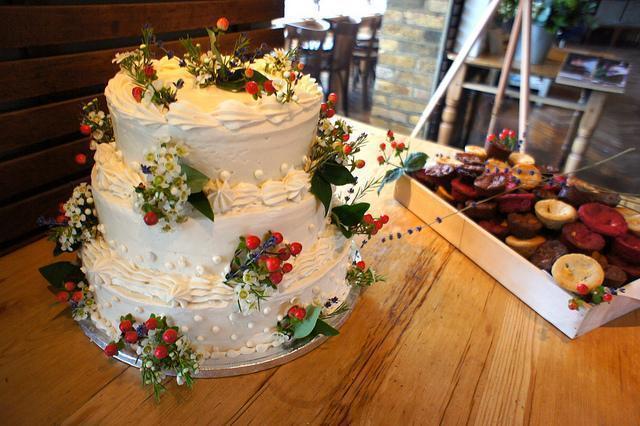Bakers usually charge by the what to make these items?
Choose the correct response and explain in the format: 'Answer: answer
Rationale: rationale.'
Options: Hour, slice, minute, weight. Answer: slice.
Rationale: Most bakeries charge by the weight and time it takes for them to make it. 